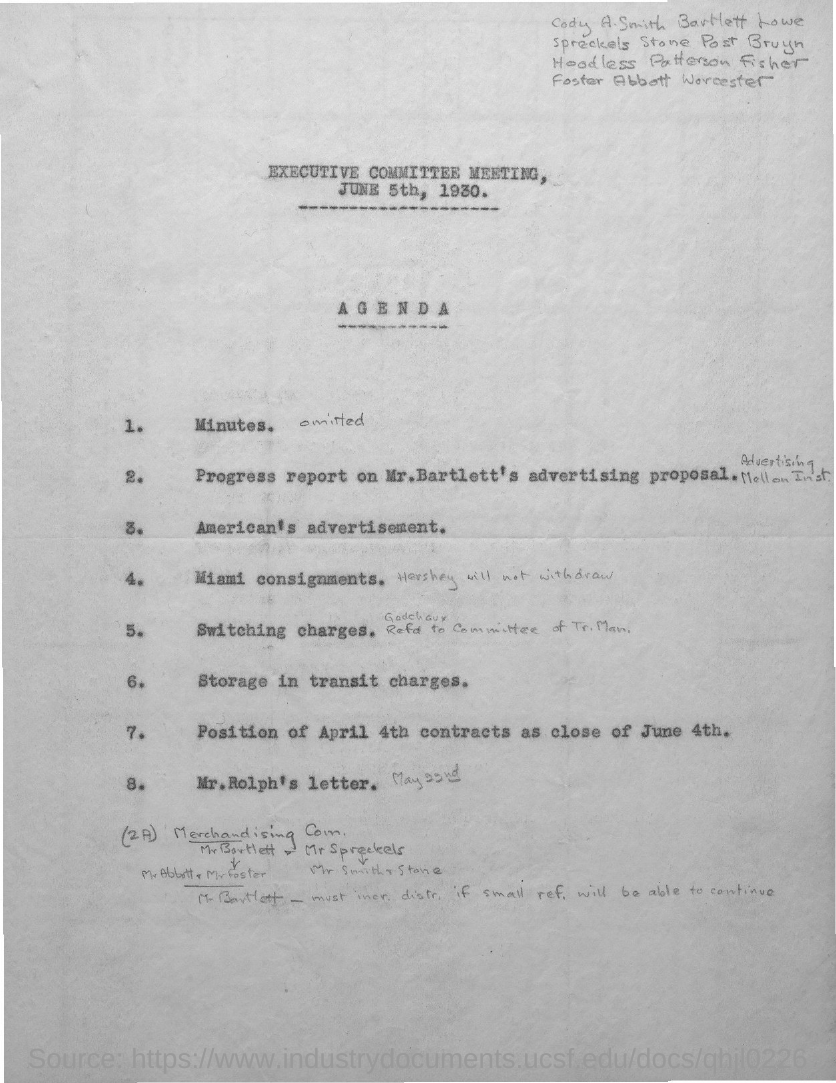Identify some key points in this picture. The agenda item number 6 is related to storage in transit charges. The agenda number 3 pertains to the American advertisement of a product. 